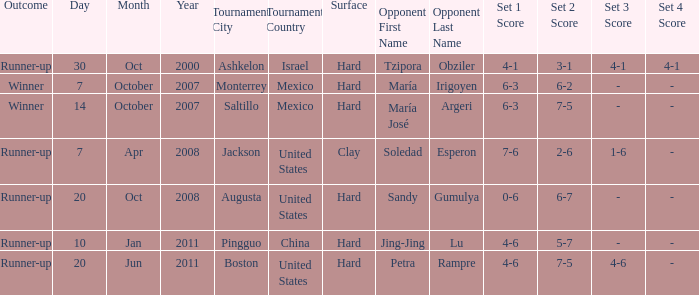Which tournament was held on October 14, 2007? Saltillo , Mexico. 